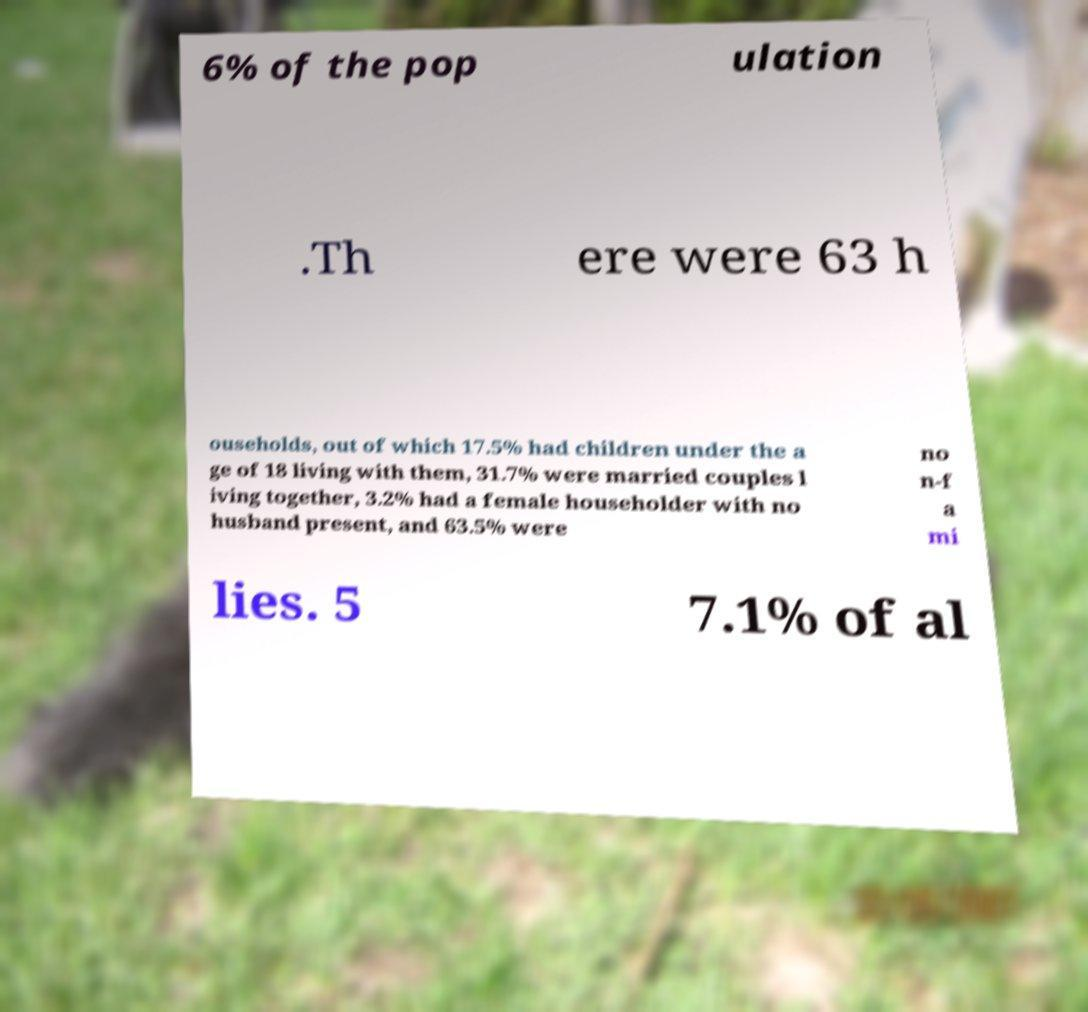Could you extract and type out the text from this image? 6% of the pop ulation .Th ere were 63 h ouseholds, out of which 17.5% had children under the a ge of 18 living with them, 31.7% were married couples l iving together, 3.2% had a female householder with no husband present, and 63.5% were no n-f a mi lies. 5 7.1% of al 